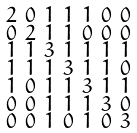Convert formula to latex. <formula><loc_0><loc_0><loc_500><loc_500>\begin{smallmatrix} 2 & 0 & 1 & 1 & 1 & 0 & 0 \\ 0 & 2 & 1 & 1 & 0 & 0 & 0 \\ 1 & 1 & 3 & 1 & 1 & 1 & 1 \\ 1 & 1 & 1 & 3 & 1 & 1 & 0 \\ 1 & 0 & 1 & 1 & 3 & 1 & 1 \\ 0 & 0 & 1 & 1 & 1 & 3 & 0 \\ 0 & 0 & 1 & 0 & 1 & 0 & 3 \end{smallmatrix}</formula> 